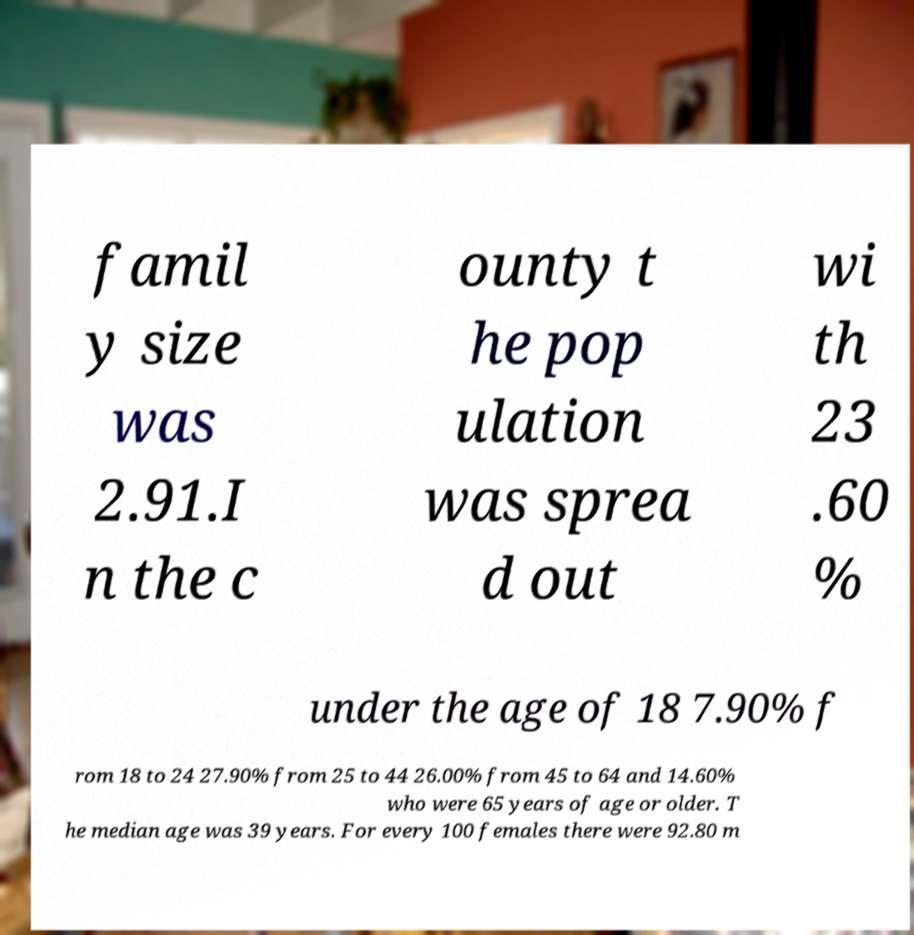Could you extract and type out the text from this image? famil y size was 2.91.I n the c ounty t he pop ulation was sprea d out wi th 23 .60 % under the age of 18 7.90% f rom 18 to 24 27.90% from 25 to 44 26.00% from 45 to 64 and 14.60% who were 65 years of age or older. T he median age was 39 years. For every 100 females there were 92.80 m 